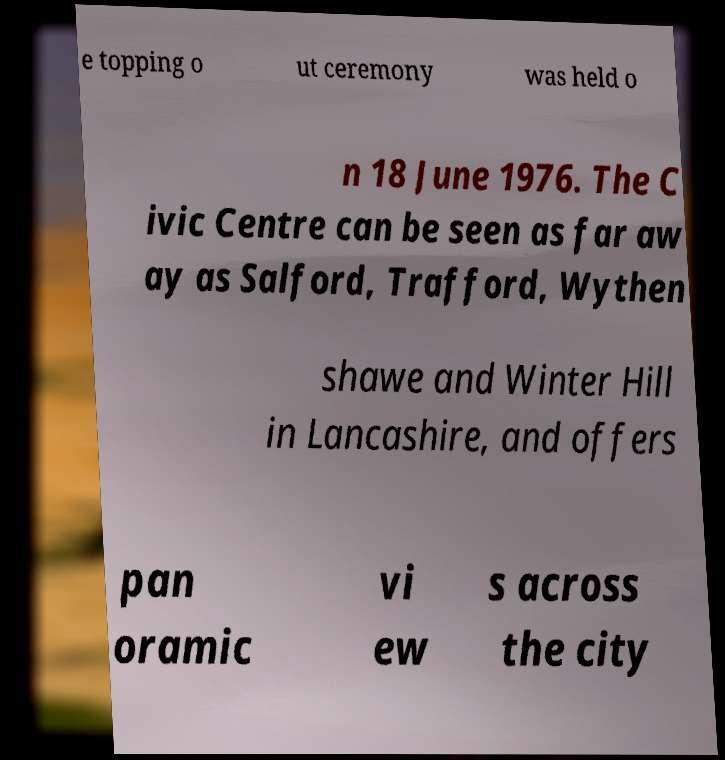Can you read and provide the text displayed in the image?This photo seems to have some interesting text. Can you extract and type it out for me? e topping o ut ceremony was held o n 18 June 1976. The C ivic Centre can be seen as far aw ay as Salford, Trafford, Wythen shawe and Winter Hill in Lancashire, and offers pan oramic vi ew s across the city 